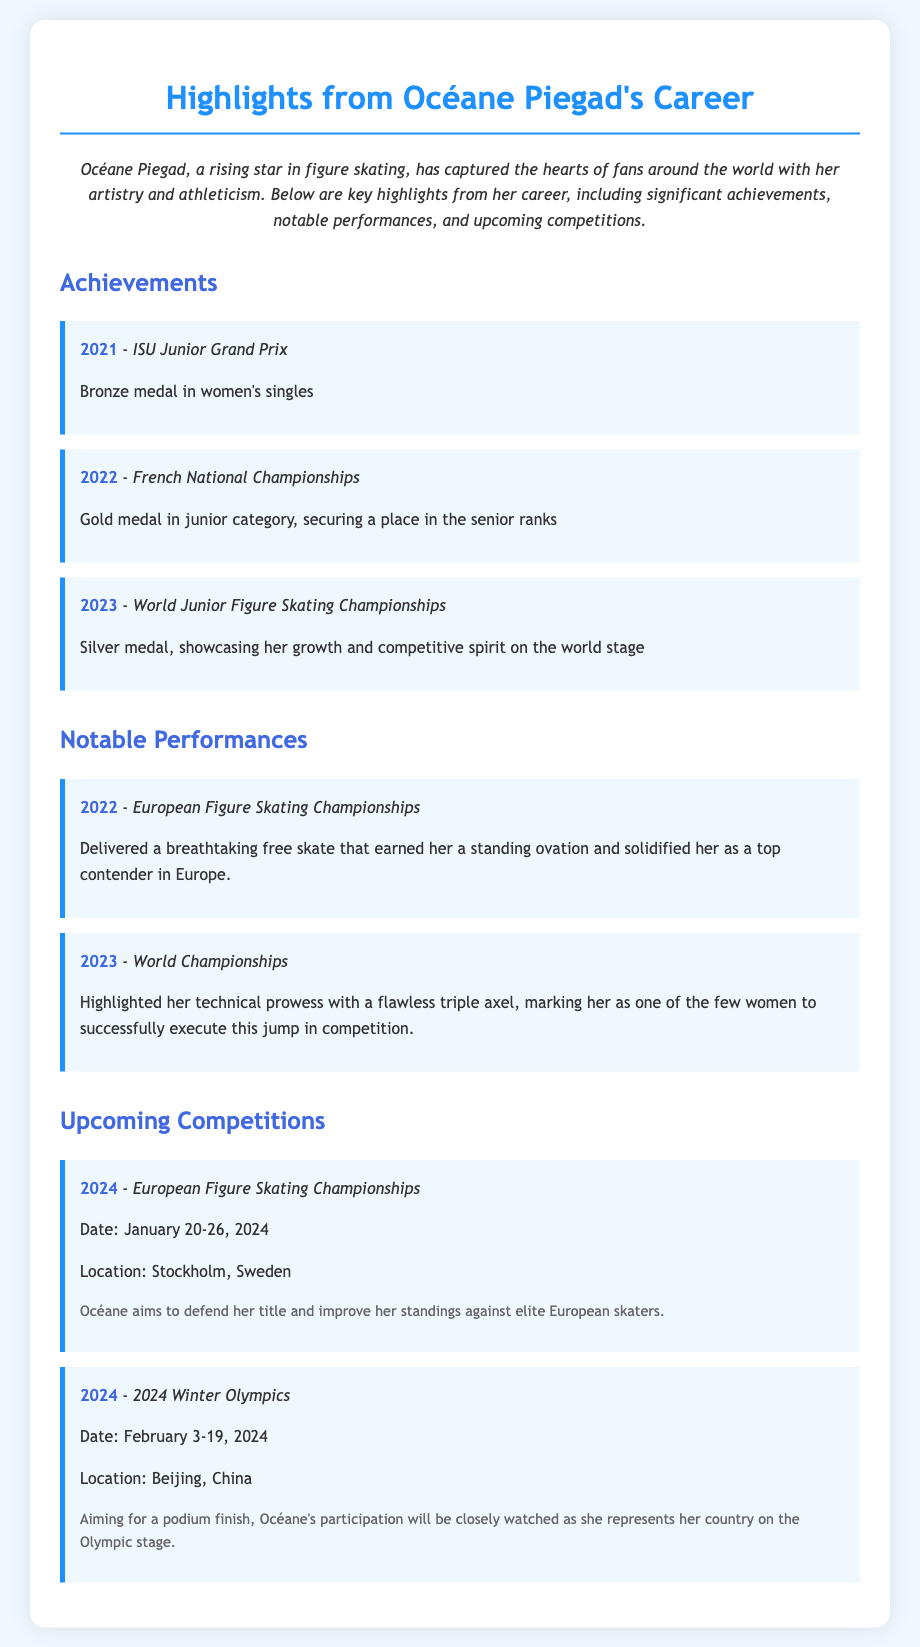What medal did Océane win at the 2021 ISU Junior Grand Prix? The document states that Océane won a bronze medal in women's singles at the 2021 ISU Junior Grand Prix.
Answer: Bronze medal What significant achievement did Océane attain in 2022? According to the document, she won a gold medal in the junior category at the French National Championships, securing a place in the senior ranks.
Answer: Gold medal In which competition did Océane execute a flawless triple axel? The document mentions that she highlighted her technical prowess with a flawless triple axel at the 2023 World Championships.
Answer: World Championships What year is Océane aiming to defend her title at the European Figure Skating Championships? The document indicates that Océane is aiming to defend her title in 2024.
Answer: 2024 What is the date range for the 2024 Winter Olympics? The event schedule in the document specifies that the 2024 Winter Olympics will occur from February 3-19, 2024.
Answer: February 3-19, 2024 Which notable performance earned Océane a standing ovation? The document highlights her performance at the 2022 European Figure Skating Championships as one that earned a standing ovation.
Answer: 2022 European Figure Skating Championships What is the location of the upcoming 2024 European Figure Skating Championships? The document specifies that the 2024 European Figure Skating Championships will take place in Stockholm, Sweden.
Answer: Stockholm, Sweden What color medal did Océane win at the 2023 World Junior Figure Skating Championships? The document states that Océane won a silver medal at the 2023 World Junior Figure Skating Championships.
Answer: Silver medal 